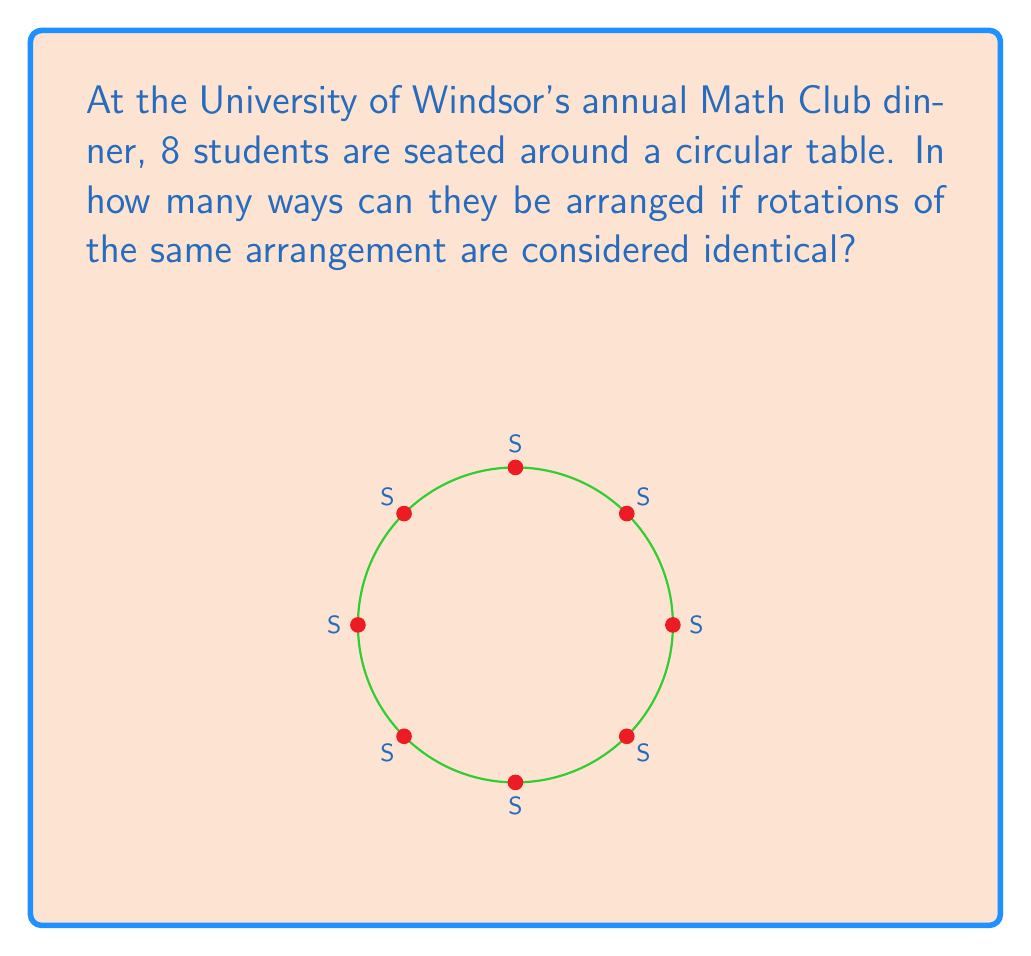Help me with this question. Let's approach this step-by-step:

1) First, recall that for a circular arrangement, rotations are considered the same. This means we can fix one person's position and arrange the rest.

2) We have 8 students in total. Let's fix the position of one student. This leaves us with 7 students to arrange.

3) These 7 students can be arranged in 7! ways.

4) The formula for circular permutations is:
   $$(n-1)!$$
   where $n$ is the total number of elements.

5) In this case, $n = 8$, so we calculate:
   $$(8-1)! = 7!$$

6) Let's compute 7!:
   $$7! = 7 \times 6 \times 5 \times 4 \times 3 \times 2 \times 1 = 5040$$

Therefore, there are 5040 unique seating arrangements for the 8 students around the circular table.
Answer: 5040 